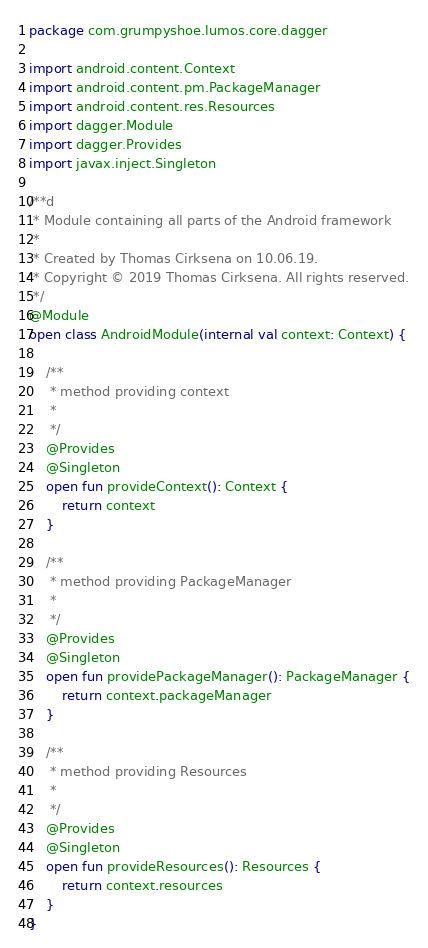<code> <loc_0><loc_0><loc_500><loc_500><_Kotlin_>package com.grumpyshoe.lumos.core.dagger

import android.content.Context
import android.content.pm.PackageManager
import android.content.res.Resources
import dagger.Module
import dagger.Provides
import javax.inject.Singleton

/**d
 * Module containing all parts of the Android framework
 *
 * Created by Thomas Cirksena on 10.06.19.
 * Copyright © 2019 Thomas Cirksena. All rights reserved.
 */
@Module
open class AndroidModule(internal val context: Context) {

    /**
     * method providing context
     *
     */
    @Provides
    @Singleton
    open fun provideContext(): Context {
        return context
    }

    /**
     * method providing PackageManager
     *
     */
    @Provides
    @Singleton
    open fun providePackageManager(): PackageManager {
        return context.packageManager
    }

    /**
     * method providing Resources
     *
     */
    @Provides
    @Singleton
    open fun provideResources(): Resources {
        return context.resources
    }
}</code> 